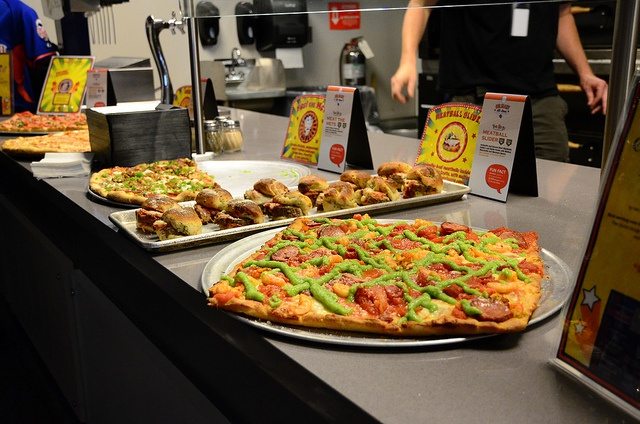Describe the objects in this image and their specific colors. I can see pizza in darkblue, orange, red, olive, and brown tones, people in darkblue, black, salmon, tan, and brown tones, people in darkblue, black, navy, and maroon tones, pizza in darkblue, orange, olive, and gold tones, and pizza in darkblue, orange, gold, olive, and red tones in this image. 